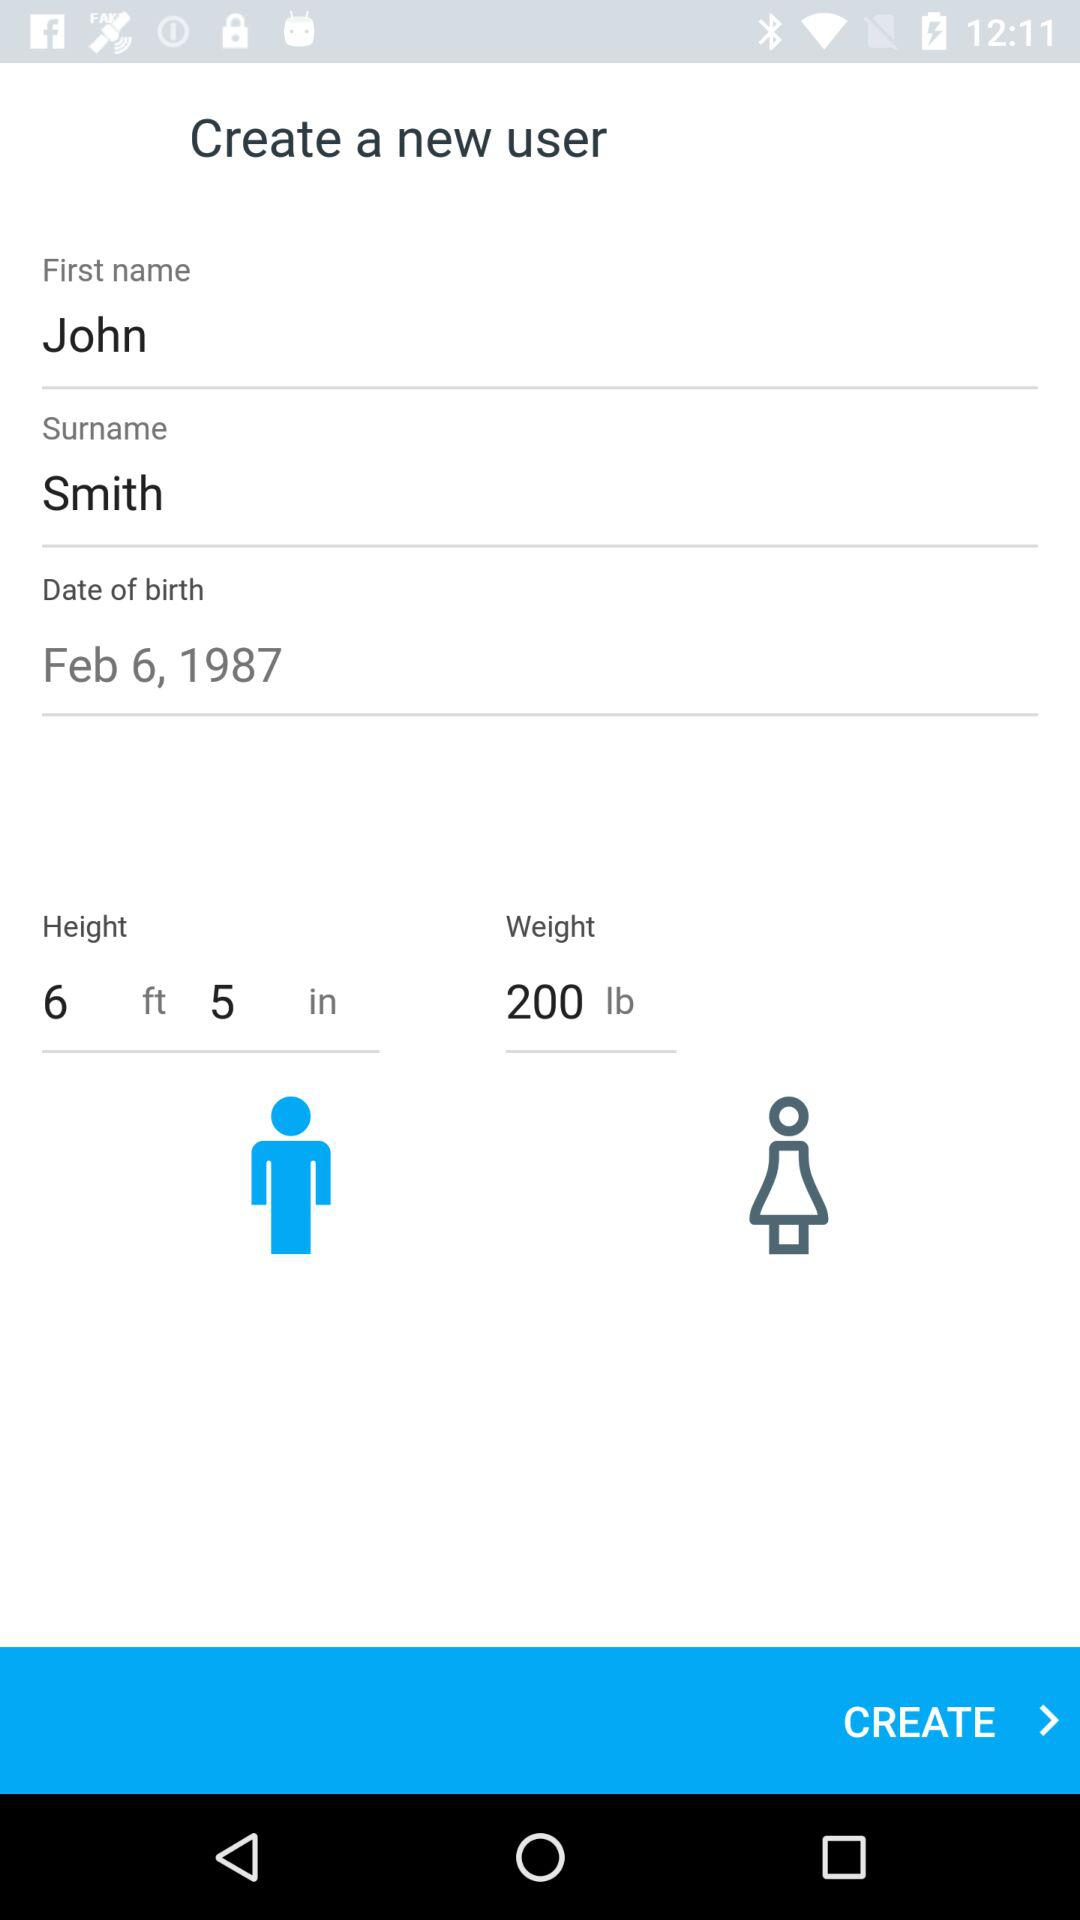Which gender is selected? The selected gender is male. 